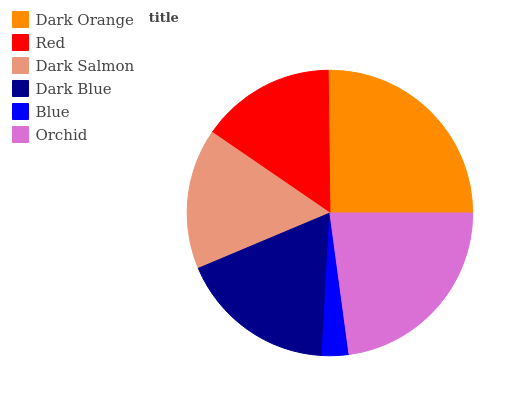Is Blue the minimum?
Answer yes or no. Yes. Is Dark Orange the maximum?
Answer yes or no. Yes. Is Red the minimum?
Answer yes or no. No. Is Red the maximum?
Answer yes or no. No. Is Dark Orange greater than Red?
Answer yes or no. Yes. Is Red less than Dark Orange?
Answer yes or no. Yes. Is Red greater than Dark Orange?
Answer yes or no. No. Is Dark Orange less than Red?
Answer yes or no. No. Is Dark Blue the high median?
Answer yes or no. Yes. Is Dark Salmon the low median?
Answer yes or no. Yes. Is Orchid the high median?
Answer yes or no. No. Is Red the low median?
Answer yes or no. No. 